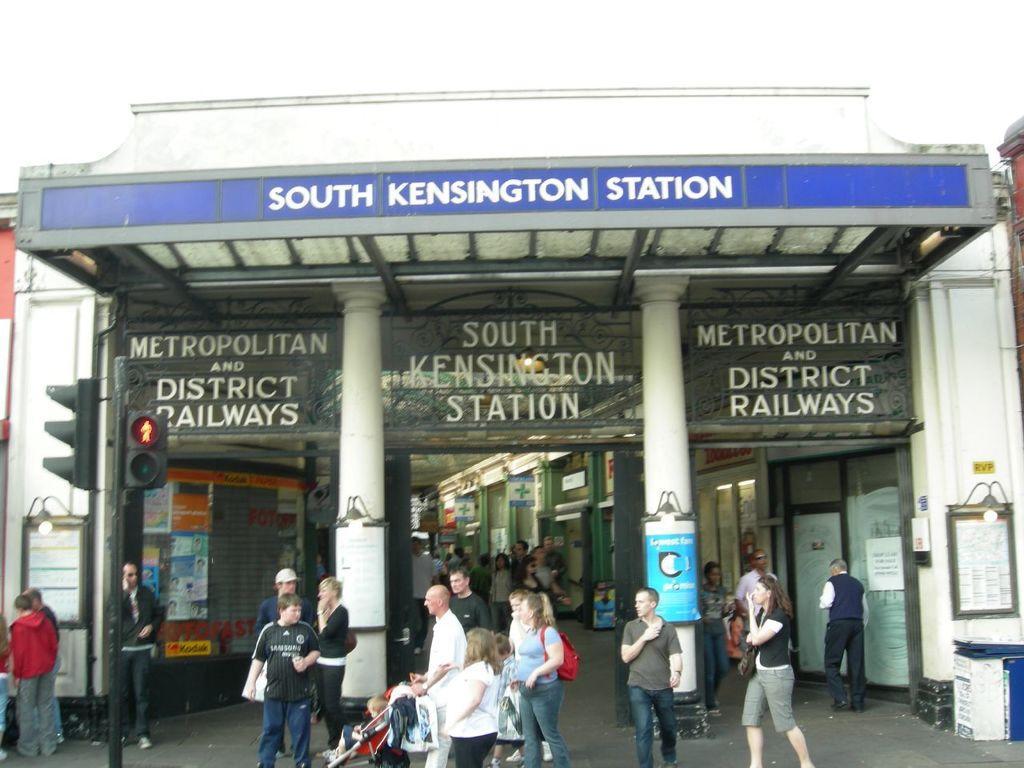Could you give a brief overview of what you see in this image? In this picture we can see some people are walking, in the background there is a building, on the left side we can see traffic lights, a man in the middle is holding a stroller, on the right side there is a board, we can see two pillars and boards in the middle, we can see some text on these boards, we can also see birds in the background. 